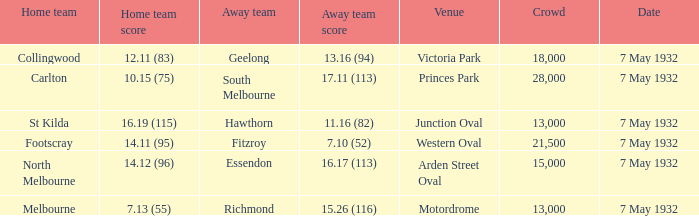What is the overall attendance when the home team's score is 14.12 (96)? 15000.0. 